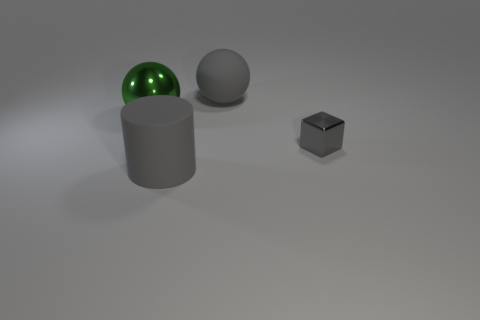There is a matte thing behind the matte object that is in front of the large gray ball; what is its shape?
Provide a succinct answer. Sphere. How many other objects are there of the same shape as the tiny thing?
Give a very brief answer. 0. Are there any large cylinders right of the small metallic object?
Offer a very short reply. No. What is the color of the matte cylinder?
Offer a terse response. Gray. Do the tiny thing and the large object on the left side of the rubber cylinder have the same color?
Your response must be concise. No. Is there a gray ball that has the same size as the cylinder?
Your answer should be compact. Yes. What size is the rubber sphere that is the same color as the cube?
Ensure brevity in your answer.  Large. What is the material of the big green sphere that is on the left side of the shiny block?
Your answer should be compact. Metal. Is the number of big green spheres left of the green ball the same as the number of large green spheres behind the tiny shiny object?
Provide a succinct answer. No. There is a metallic ball left of the gray rubber cylinder; is its size the same as the gray thing that is in front of the tiny gray object?
Offer a very short reply. Yes. 